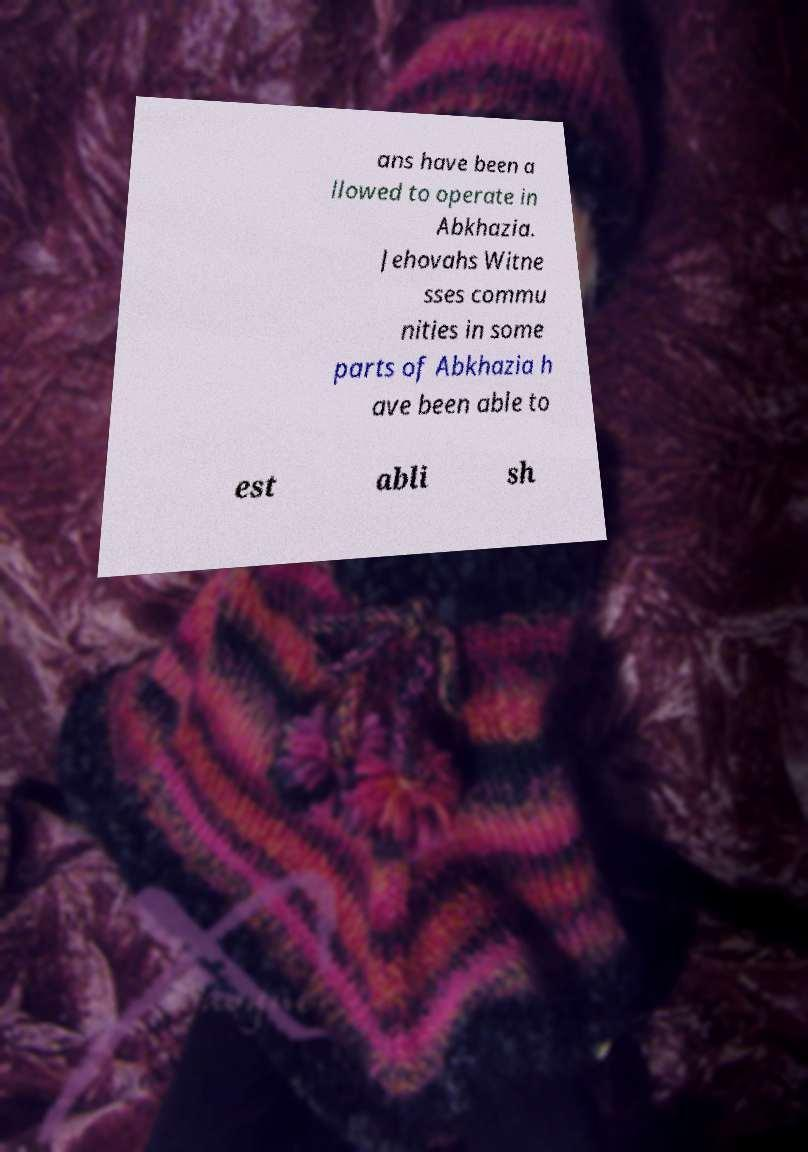Can you read and provide the text displayed in the image?This photo seems to have some interesting text. Can you extract and type it out for me? ans have been a llowed to operate in Abkhazia. Jehovahs Witne sses commu nities in some parts of Abkhazia h ave been able to est abli sh 